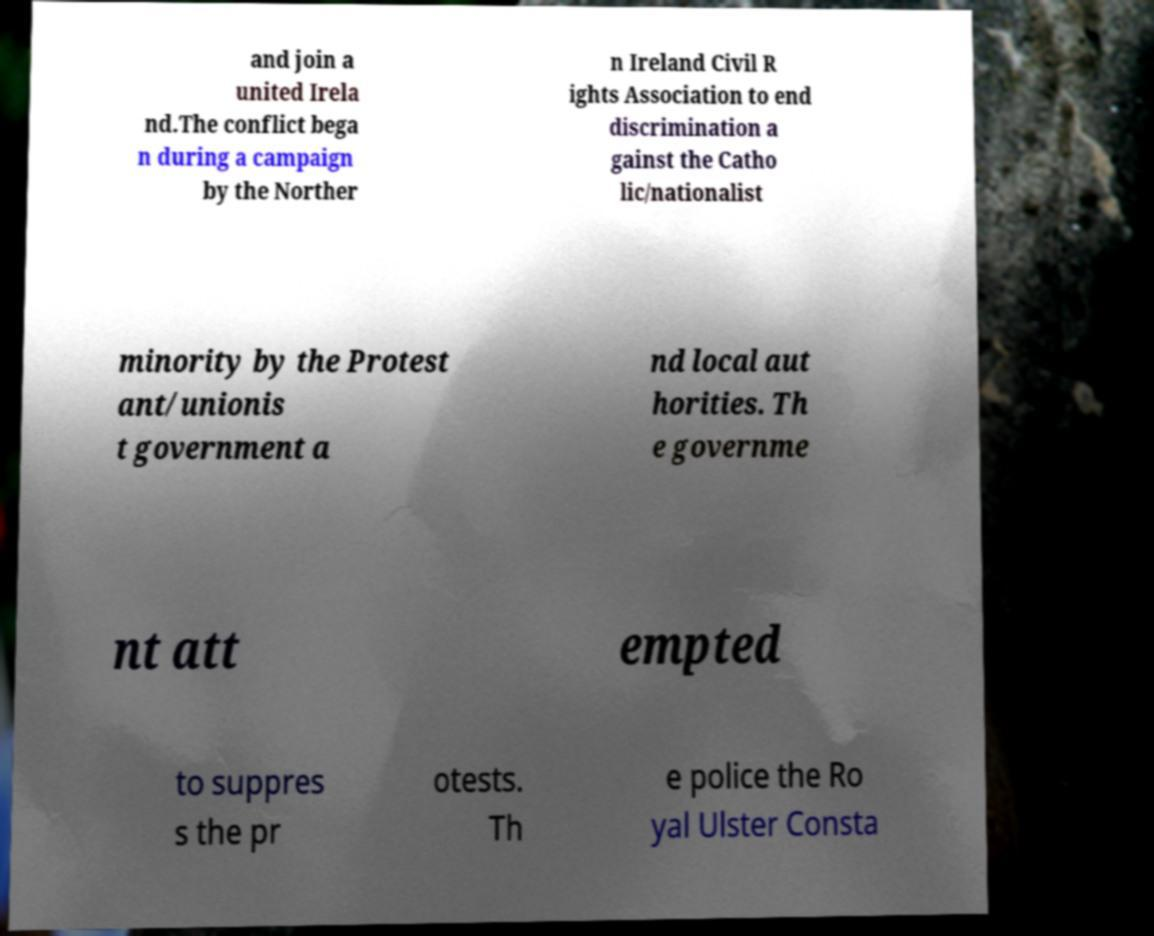What messages or text are displayed in this image? I need them in a readable, typed format. and join a united Irela nd.The conflict bega n during a campaign by the Norther n Ireland Civil R ights Association to end discrimination a gainst the Catho lic/nationalist minority by the Protest ant/unionis t government a nd local aut horities. Th e governme nt att empted to suppres s the pr otests. Th e police the Ro yal Ulster Consta 